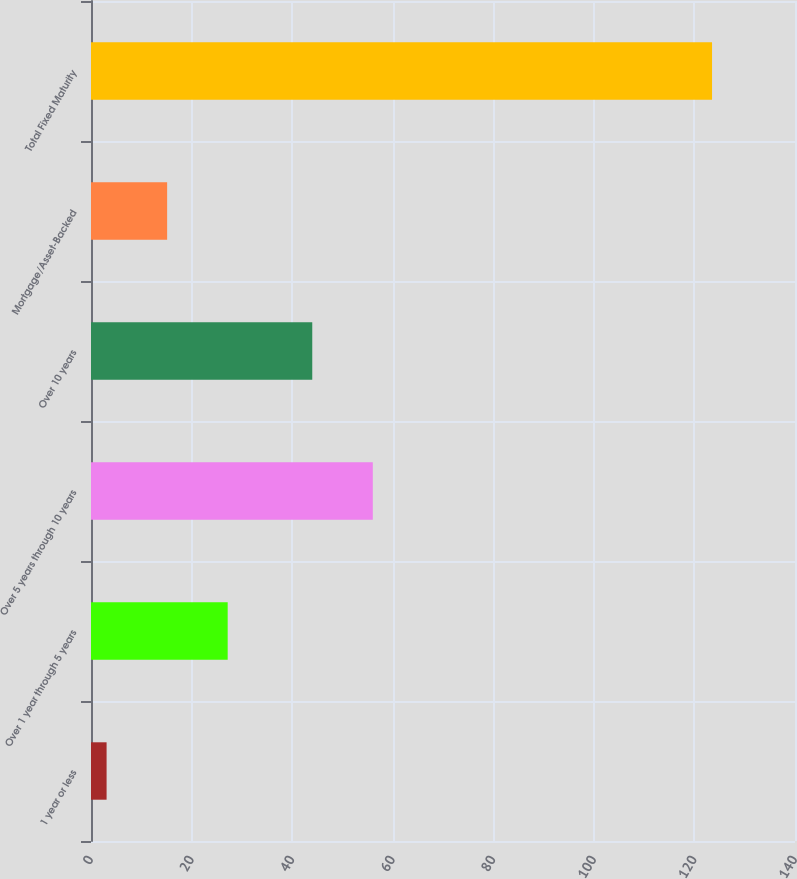Convert chart to OTSL. <chart><loc_0><loc_0><loc_500><loc_500><bar_chart><fcel>1 year or less<fcel>Over 1 year through 5 years<fcel>Over 5 years through 10 years<fcel>Over 10 years<fcel>Mortgage/Asset-Backed<fcel>Total Fixed Maturity<nl><fcel>3.1<fcel>27.18<fcel>56.04<fcel>44<fcel>15.14<fcel>123.5<nl></chart> 